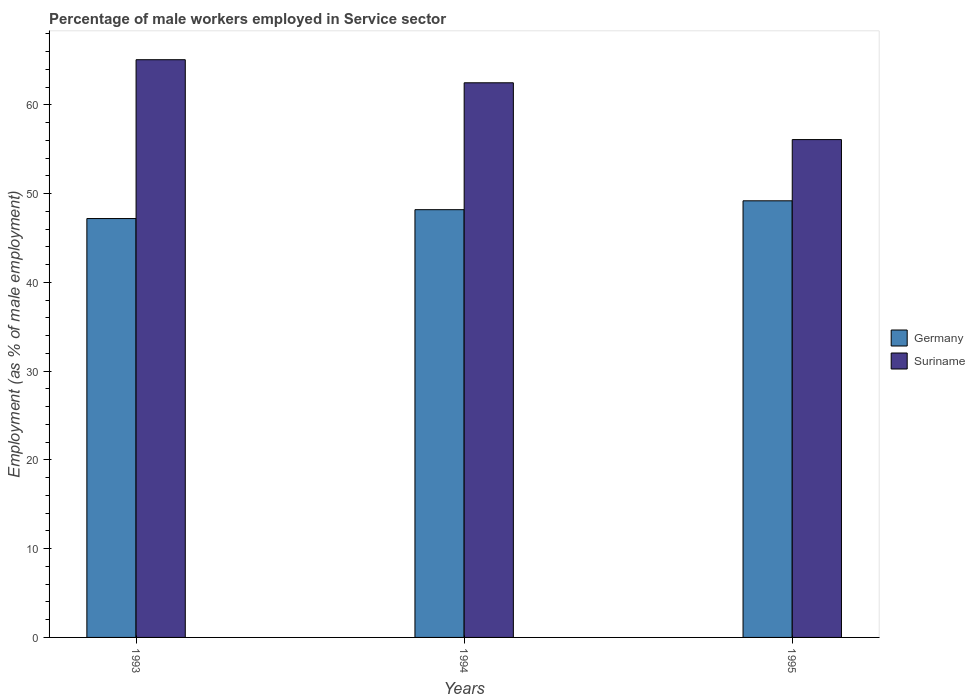Are the number of bars per tick equal to the number of legend labels?
Your answer should be very brief. Yes. How many bars are there on the 1st tick from the right?
Offer a terse response. 2. What is the label of the 2nd group of bars from the left?
Keep it short and to the point. 1994. In how many cases, is the number of bars for a given year not equal to the number of legend labels?
Ensure brevity in your answer.  0. What is the percentage of male workers employed in Service sector in Suriname in 1995?
Provide a succinct answer. 56.1. Across all years, what is the maximum percentage of male workers employed in Service sector in Germany?
Make the answer very short. 49.2. Across all years, what is the minimum percentage of male workers employed in Service sector in Germany?
Your answer should be very brief. 47.2. In which year was the percentage of male workers employed in Service sector in Germany maximum?
Ensure brevity in your answer.  1995. In which year was the percentage of male workers employed in Service sector in Germany minimum?
Offer a terse response. 1993. What is the total percentage of male workers employed in Service sector in Suriname in the graph?
Provide a short and direct response. 183.7. What is the difference between the percentage of male workers employed in Service sector in Suriname in 1993 and that in 1995?
Provide a short and direct response. 9. What is the difference between the percentage of male workers employed in Service sector in Suriname in 1993 and the percentage of male workers employed in Service sector in Germany in 1994?
Ensure brevity in your answer.  16.9. What is the average percentage of male workers employed in Service sector in Suriname per year?
Offer a terse response. 61.23. In the year 1993, what is the difference between the percentage of male workers employed in Service sector in Suriname and percentage of male workers employed in Service sector in Germany?
Ensure brevity in your answer.  17.9. In how many years, is the percentage of male workers employed in Service sector in Germany greater than 22 %?
Provide a short and direct response. 3. What is the ratio of the percentage of male workers employed in Service sector in Germany in 1993 to that in 1995?
Keep it short and to the point. 0.96. Is the difference between the percentage of male workers employed in Service sector in Suriname in 1994 and 1995 greater than the difference between the percentage of male workers employed in Service sector in Germany in 1994 and 1995?
Offer a very short reply. Yes. What is the difference between the highest and the second highest percentage of male workers employed in Service sector in Suriname?
Ensure brevity in your answer.  2.6. What is the difference between the highest and the lowest percentage of male workers employed in Service sector in Germany?
Keep it short and to the point. 2. What does the 1st bar from the left in 1994 represents?
Ensure brevity in your answer.  Germany. What does the 1st bar from the right in 1993 represents?
Offer a very short reply. Suriname. Are all the bars in the graph horizontal?
Your response must be concise. No. How many years are there in the graph?
Provide a short and direct response. 3. Does the graph contain any zero values?
Your answer should be compact. No. Does the graph contain grids?
Your answer should be compact. No. Where does the legend appear in the graph?
Give a very brief answer. Center right. What is the title of the graph?
Provide a succinct answer. Percentage of male workers employed in Service sector. What is the label or title of the Y-axis?
Keep it short and to the point. Employment (as % of male employment). What is the Employment (as % of male employment) of Germany in 1993?
Your response must be concise. 47.2. What is the Employment (as % of male employment) in Suriname in 1993?
Provide a short and direct response. 65.1. What is the Employment (as % of male employment) in Germany in 1994?
Your answer should be compact. 48.2. What is the Employment (as % of male employment) in Suriname in 1994?
Your response must be concise. 62.5. What is the Employment (as % of male employment) of Germany in 1995?
Keep it short and to the point. 49.2. What is the Employment (as % of male employment) of Suriname in 1995?
Offer a terse response. 56.1. Across all years, what is the maximum Employment (as % of male employment) of Germany?
Keep it short and to the point. 49.2. Across all years, what is the maximum Employment (as % of male employment) of Suriname?
Your answer should be compact. 65.1. Across all years, what is the minimum Employment (as % of male employment) of Germany?
Your answer should be compact. 47.2. Across all years, what is the minimum Employment (as % of male employment) of Suriname?
Provide a succinct answer. 56.1. What is the total Employment (as % of male employment) in Germany in the graph?
Provide a succinct answer. 144.6. What is the total Employment (as % of male employment) in Suriname in the graph?
Offer a terse response. 183.7. What is the difference between the Employment (as % of male employment) in Suriname in 1993 and that in 1994?
Make the answer very short. 2.6. What is the difference between the Employment (as % of male employment) in Germany in 1993 and that in 1995?
Your answer should be very brief. -2. What is the difference between the Employment (as % of male employment) of Suriname in 1993 and that in 1995?
Provide a succinct answer. 9. What is the difference between the Employment (as % of male employment) in Germany in 1993 and the Employment (as % of male employment) in Suriname in 1994?
Provide a succinct answer. -15.3. What is the average Employment (as % of male employment) of Germany per year?
Your answer should be compact. 48.2. What is the average Employment (as % of male employment) of Suriname per year?
Offer a terse response. 61.23. In the year 1993, what is the difference between the Employment (as % of male employment) of Germany and Employment (as % of male employment) of Suriname?
Offer a terse response. -17.9. In the year 1994, what is the difference between the Employment (as % of male employment) of Germany and Employment (as % of male employment) of Suriname?
Ensure brevity in your answer.  -14.3. In the year 1995, what is the difference between the Employment (as % of male employment) in Germany and Employment (as % of male employment) in Suriname?
Ensure brevity in your answer.  -6.9. What is the ratio of the Employment (as % of male employment) of Germany in 1993 to that in 1994?
Provide a succinct answer. 0.98. What is the ratio of the Employment (as % of male employment) of Suriname in 1993 to that in 1994?
Give a very brief answer. 1.04. What is the ratio of the Employment (as % of male employment) of Germany in 1993 to that in 1995?
Give a very brief answer. 0.96. What is the ratio of the Employment (as % of male employment) of Suriname in 1993 to that in 1995?
Offer a very short reply. 1.16. What is the ratio of the Employment (as % of male employment) of Germany in 1994 to that in 1995?
Your answer should be very brief. 0.98. What is the ratio of the Employment (as % of male employment) of Suriname in 1994 to that in 1995?
Ensure brevity in your answer.  1.11. What is the difference between the highest and the second highest Employment (as % of male employment) in Germany?
Provide a succinct answer. 1. What is the difference between the highest and the lowest Employment (as % of male employment) of Germany?
Provide a short and direct response. 2. What is the difference between the highest and the lowest Employment (as % of male employment) of Suriname?
Keep it short and to the point. 9. 